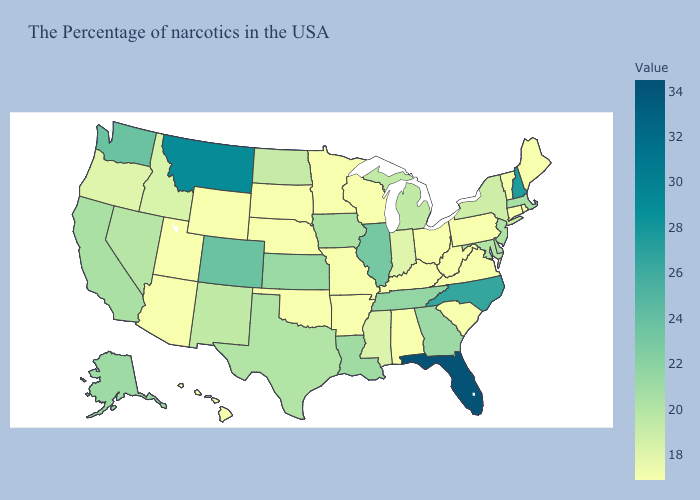Does Washington have a higher value than North Carolina?
Answer briefly. No. Does Maine have a lower value than Colorado?
Keep it brief. Yes. Does Virginia have the lowest value in the USA?
Quick response, please. Yes. Among the states that border West Virginia , does Maryland have the lowest value?
Quick response, please. No. Among the states that border Massachusetts , does Rhode Island have the lowest value?
Keep it brief. Yes. Among the states that border New Hampshire , does Maine have the lowest value?
Concise answer only. Yes. Among the states that border Arkansas , does Mississippi have the highest value?
Write a very short answer. No. Which states have the highest value in the USA?
Short answer required. Florida. 